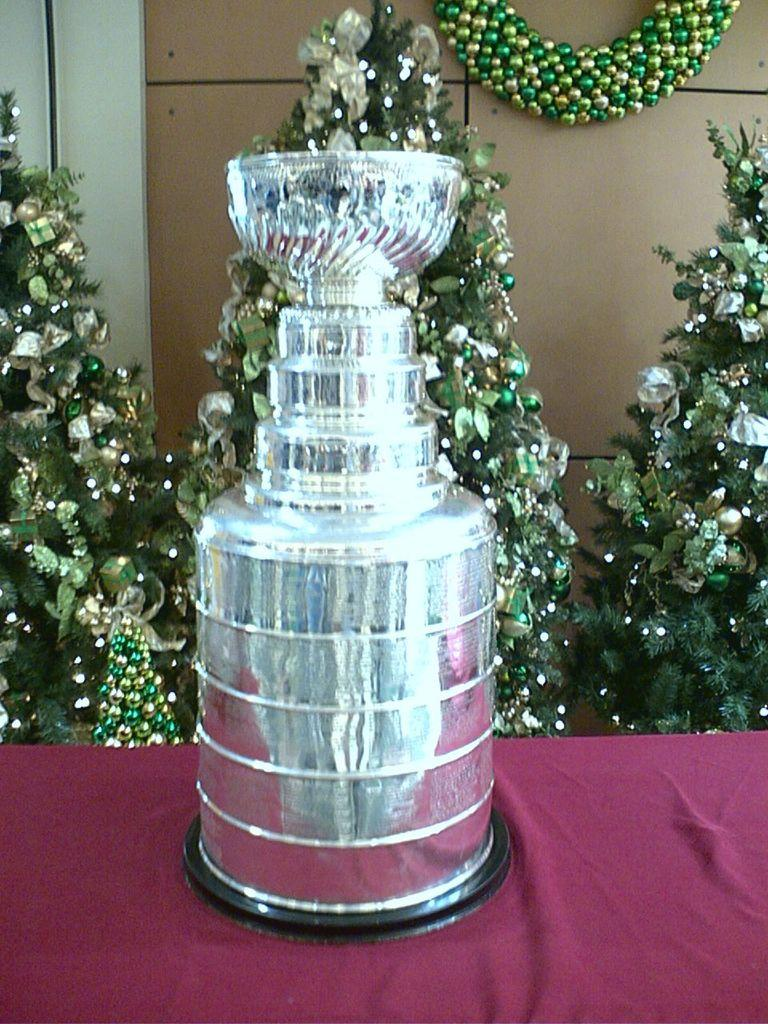What is the color of the object in the image? The object in the image is silver-colored. What is the object placed on? The silver-colored object is on a pink cloth. What can be seen in the background of the image? There are Christmas trees in the background of the image. Can you describe any decorative elements in the background? Yes, there is a decorative object attached to the wall in the background. How does the silver-colored object express its feelings in the image? The silver-colored object does not express feelings, as it is an inanimate object. 